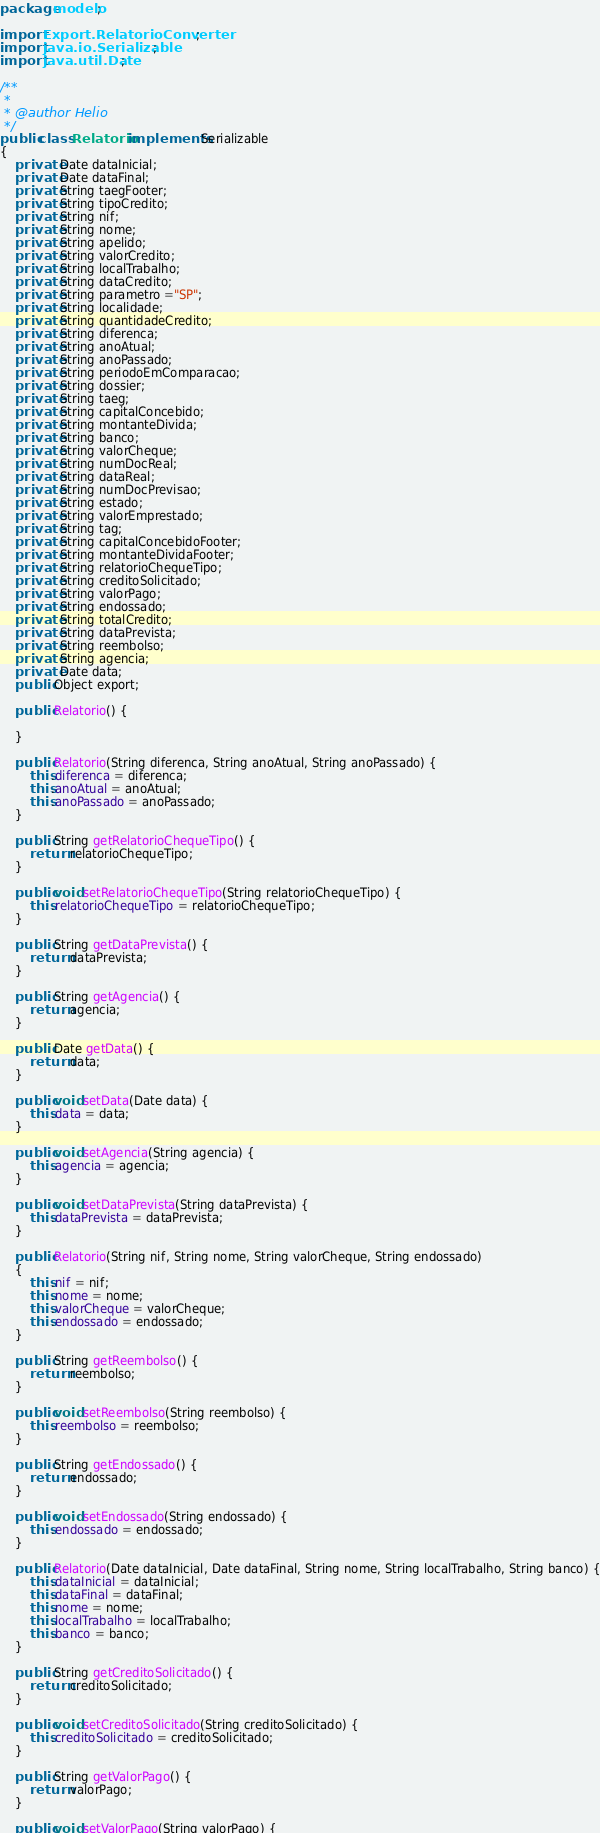Convert code to text. <code><loc_0><loc_0><loc_500><loc_500><_Java_>
package modelo;

import Export.RelatorioConverter;
import java.io.Serializable;
import java.util.Date;

/**
 *
 * @author Helio
 */
public class Relatorio implements Serializable
{
    private Date dataInicial;
    private Date dataFinal;
    private String taegFooter;
    private String tipoCredito;
    private String nif;
    private String nome;
    private String apelido;
    private String valorCredito;
    private String localTrabalho;
    private String dataCredito;
    private String parametro ="SP";
    private String localidade;
    private String quantidadeCredito;
    private String diferenca;
    private String anoAtual;
    private String anoPassado;
    private String periodoEmComparacao;
    private String dossier;
    private String taeg;
    private String capitalConcebido;
    private String montanteDivida;
    private String banco;
    private String valorCheque;
    private String numDocReal;
    private String dataReal;
    private String numDocPrevisao;
    private String estado;
    private String valorEmprestado;
    private String tag;
    private String capitalConcebidoFooter;
    private String montanteDividaFooter;
    private String relatorioChequeTipo;
    private String creditoSolicitado;
    private String valorPago;
    private String endossado;
    private String totalCredito;
    private String dataPrevista;
    private String reembolso;
    private String agencia;
    private Date data;
    public Object export;
    
    public Relatorio() {
 
    }

    public Relatorio(String diferenca, String anoAtual, String anoPassado) {
        this.diferenca = diferenca;
        this.anoAtual = anoAtual;
        this.anoPassado = anoPassado;
    }

    public String getRelatorioChequeTipo() {
        return relatorioChequeTipo;
    }

    public void setRelatorioChequeTipo(String relatorioChequeTipo) {
        this.relatorioChequeTipo = relatorioChequeTipo;
    }

    public String getDataPrevista() {
        return dataPrevista;
    }

    public String getAgencia() {
        return agencia;
    }

    public Date getData() {
        return data;
    }

    public void setData(Date data) {
        this.data = data;
    }

    public void setAgencia(String agencia) {
        this.agencia = agencia;
    }

    public void setDataPrevista(String dataPrevista) {
        this.dataPrevista = dataPrevista;
    }

    public Relatorio(String nif, String nome, String valorCheque, String endossado)
    {
        this.nif = nif;
        this.nome = nome;
        this.valorCheque = valorCheque;
        this.endossado = endossado;
    }

    public String getReembolso() {
        return reembolso;
    }

    public void setReembolso(String reembolso) {
        this.reembolso = reembolso;
    }
    
    public String getEndossado() {
        return endossado;
    }

    public void setEndossado(String endossado) {
        this.endossado = endossado;
    }

    public Relatorio(Date dataInicial, Date dataFinal, String nome, String localTrabalho, String banco) {
        this.dataInicial = dataInicial;
        this.dataFinal = dataFinal;
        this.nome = nome;
        this.localTrabalho = localTrabalho;
        this.banco = banco;
    }

    public String getCreditoSolicitado() {
        return creditoSolicitado;
    }

    public void setCreditoSolicitado(String creditoSolicitado) {
        this.creditoSolicitado = creditoSolicitado;
    }

    public String getValorPago() {
        return valorPago;
    }

    public void setValorPago(String valorPago) {</code> 